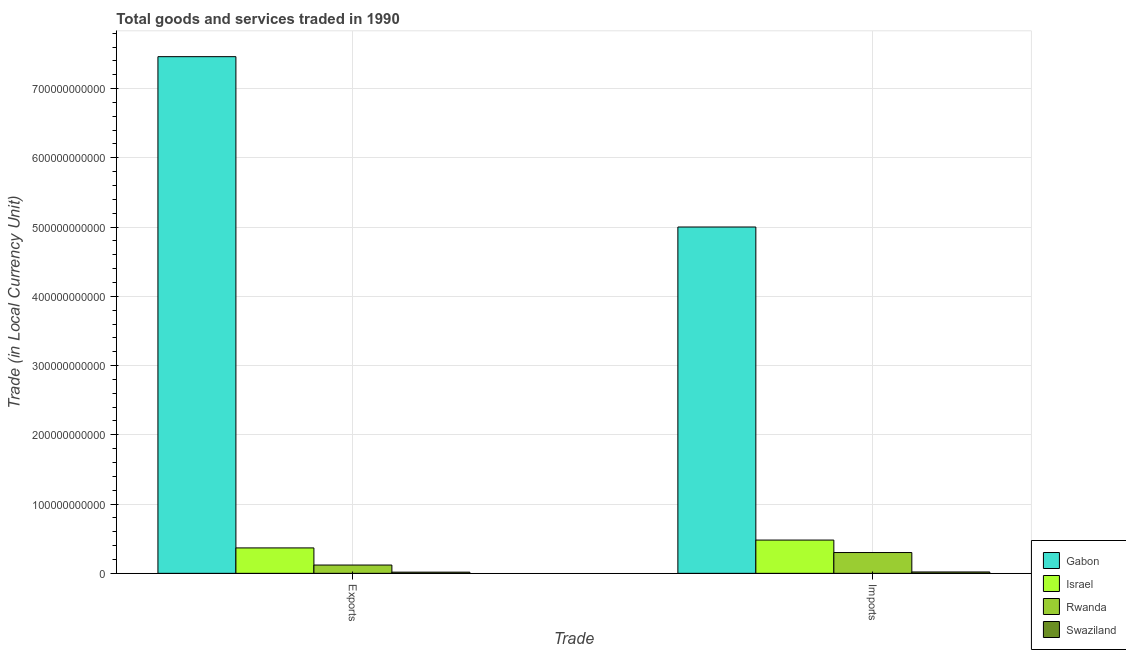How many different coloured bars are there?
Give a very brief answer. 4. How many groups of bars are there?
Provide a succinct answer. 2. What is the label of the 1st group of bars from the left?
Give a very brief answer. Exports. What is the export of goods and services in Israel?
Your answer should be compact. 3.67e+1. Across all countries, what is the maximum export of goods and services?
Your answer should be compact. 7.46e+11. Across all countries, what is the minimum export of goods and services?
Your answer should be compact. 1.70e+09. In which country was the imports of goods and services maximum?
Your response must be concise. Gabon. In which country was the imports of goods and services minimum?
Provide a succinct answer. Swaziland. What is the total export of goods and services in the graph?
Provide a short and direct response. 7.97e+11. What is the difference between the export of goods and services in Gabon and that in Israel?
Provide a succinct answer. 7.09e+11. What is the difference between the export of goods and services in Rwanda and the imports of goods and services in Israel?
Provide a short and direct response. -3.60e+1. What is the average export of goods and services per country?
Provide a succinct answer. 1.99e+11. What is the difference between the export of goods and services and imports of goods and services in Israel?
Give a very brief answer. -1.13e+1. What is the ratio of the imports of goods and services in Rwanda to that in Israel?
Offer a very short reply. 0.63. Is the imports of goods and services in Israel less than that in Rwanda?
Provide a short and direct response. No. What does the 2nd bar from the left in Imports represents?
Keep it short and to the point. Israel. What does the 4th bar from the right in Imports represents?
Keep it short and to the point. Gabon. How many bars are there?
Provide a succinct answer. 8. How many countries are there in the graph?
Keep it short and to the point. 4. What is the difference between two consecutive major ticks on the Y-axis?
Give a very brief answer. 1.00e+11. Are the values on the major ticks of Y-axis written in scientific E-notation?
Make the answer very short. No. Does the graph contain any zero values?
Provide a succinct answer. No. Does the graph contain grids?
Provide a succinct answer. Yes. How are the legend labels stacked?
Make the answer very short. Vertical. What is the title of the graph?
Your response must be concise. Total goods and services traded in 1990. What is the label or title of the X-axis?
Your answer should be compact. Trade. What is the label or title of the Y-axis?
Your answer should be compact. Trade (in Local Currency Unit). What is the Trade (in Local Currency Unit) of Gabon in Exports?
Ensure brevity in your answer.  7.46e+11. What is the Trade (in Local Currency Unit) in Israel in Exports?
Provide a succinct answer. 3.67e+1. What is the Trade (in Local Currency Unit) of Rwanda in Exports?
Your answer should be compact. 1.20e+1. What is the Trade (in Local Currency Unit) in Swaziland in Exports?
Provide a succinct answer. 1.70e+09. What is the Trade (in Local Currency Unit) of Gabon in Imports?
Offer a very short reply. 5.00e+11. What is the Trade (in Local Currency Unit) in Israel in Imports?
Make the answer very short. 4.80e+1. What is the Trade (in Local Currency Unit) in Rwanda in Imports?
Keep it short and to the point. 3.00e+1. What is the Trade (in Local Currency Unit) in Swaziland in Imports?
Provide a succinct answer. 1.99e+09. Across all Trade, what is the maximum Trade (in Local Currency Unit) in Gabon?
Ensure brevity in your answer.  7.46e+11. Across all Trade, what is the maximum Trade (in Local Currency Unit) of Israel?
Your answer should be very brief. 4.80e+1. Across all Trade, what is the maximum Trade (in Local Currency Unit) in Rwanda?
Offer a very short reply. 3.00e+1. Across all Trade, what is the maximum Trade (in Local Currency Unit) in Swaziland?
Offer a terse response. 1.99e+09. Across all Trade, what is the minimum Trade (in Local Currency Unit) in Gabon?
Make the answer very short. 5.00e+11. Across all Trade, what is the minimum Trade (in Local Currency Unit) of Israel?
Your response must be concise. 3.67e+1. Across all Trade, what is the minimum Trade (in Local Currency Unit) in Rwanda?
Your answer should be compact. 1.20e+1. Across all Trade, what is the minimum Trade (in Local Currency Unit) of Swaziland?
Your answer should be compact. 1.70e+09. What is the total Trade (in Local Currency Unit) of Gabon in the graph?
Provide a short and direct response. 1.25e+12. What is the total Trade (in Local Currency Unit) in Israel in the graph?
Your answer should be compact. 8.47e+1. What is the total Trade (in Local Currency Unit) in Rwanda in the graph?
Provide a short and direct response. 4.20e+1. What is the total Trade (in Local Currency Unit) of Swaziland in the graph?
Keep it short and to the point. 3.69e+09. What is the difference between the Trade (in Local Currency Unit) in Gabon in Exports and that in Imports?
Offer a terse response. 2.46e+11. What is the difference between the Trade (in Local Currency Unit) of Israel in Exports and that in Imports?
Give a very brief answer. -1.13e+1. What is the difference between the Trade (in Local Currency Unit) of Rwanda in Exports and that in Imports?
Offer a terse response. -1.80e+1. What is the difference between the Trade (in Local Currency Unit) in Swaziland in Exports and that in Imports?
Your answer should be very brief. -2.84e+08. What is the difference between the Trade (in Local Currency Unit) in Gabon in Exports and the Trade (in Local Currency Unit) in Israel in Imports?
Provide a succinct answer. 6.98e+11. What is the difference between the Trade (in Local Currency Unit) of Gabon in Exports and the Trade (in Local Currency Unit) of Rwanda in Imports?
Offer a very short reply. 7.16e+11. What is the difference between the Trade (in Local Currency Unit) in Gabon in Exports and the Trade (in Local Currency Unit) in Swaziland in Imports?
Give a very brief answer. 7.44e+11. What is the difference between the Trade (in Local Currency Unit) of Israel in Exports and the Trade (in Local Currency Unit) of Rwanda in Imports?
Your answer should be compact. 6.68e+09. What is the difference between the Trade (in Local Currency Unit) of Israel in Exports and the Trade (in Local Currency Unit) of Swaziland in Imports?
Offer a very short reply. 3.47e+1. What is the difference between the Trade (in Local Currency Unit) in Rwanda in Exports and the Trade (in Local Currency Unit) in Swaziland in Imports?
Ensure brevity in your answer.  1.00e+1. What is the average Trade (in Local Currency Unit) in Gabon per Trade?
Your answer should be very brief. 6.23e+11. What is the average Trade (in Local Currency Unit) of Israel per Trade?
Provide a succinct answer. 4.24e+1. What is the average Trade (in Local Currency Unit) of Rwanda per Trade?
Give a very brief answer. 2.10e+1. What is the average Trade (in Local Currency Unit) of Swaziland per Trade?
Your response must be concise. 1.84e+09. What is the difference between the Trade (in Local Currency Unit) in Gabon and Trade (in Local Currency Unit) in Israel in Exports?
Ensure brevity in your answer.  7.09e+11. What is the difference between the Trade (in Local Currency Unit) in Gabon and Trade (in Local Currency Unit) in Rwanda in Exports?
Your answer should be compact. 7.34e+11. What is the difference between the Trade (in Local Currency Unit) of Gabon and Trade (in Local Currency Unit) of Swaziland in Exports?
Offer a terse response. 7.44e+11. What is the difference between the Trade (in Local Currency Unit) in Israel and Trade (in Local Currency Unit) in Rwanda in Exports?
Offer a terse response. 2.47e+1. What is the difference between the Trade (in Local Currency Unit) in Israel and Trade (in Local Currency Unit) in Swaziland in Exports?
Give a very brief answer. 3.50e+1. What is the difference between the Trade (in Local Currency Unit) in Rwanda and Trade (in Local Currency Unit) in Swaziland in Exports?
Provide a succinct answer. 1.03e+1. What is the difference between the Trade (in Local Currency Unit) in Gabon and Trade (in Local Currency Unit) in Israel in Imports?
Your answer should be very brief. 4.52e+11. What is the difference between the Trade (in Local Currency Unit) of Gabon and Trade (in Local Currency Unit) of Rwanda in Imports?
Your response must be concise. 4.70e+11. What is the difference between the Trade (in Local Currency Unit) of Gabon and Trade (in Local Currency Unit) of Swaziland in Imports?
Provide a short and direct response. 4.98e+11. What is the difference between the Trade (in Local Currency Unit) in Israel and Trade (in Local Currency Unit) in Rwanda in Imports?
Make the answer very short. 1.80e+1. What is the difference between the Trade (in Local Currency Unit) of Israel and Trade (in Local Currency Unit) of Swaziland in Imports?
Keep it short and to the point. 4.60e+1. What is the difference between the Trade (in Local Currency Unit) in Rwanda and Trade (in Local Currency Unit) in Swaziland in Imports?
Your response must be concise. 2.80e+1. What is the ratio of the Trade (in Local Currency Unit) of Gabon in Exports to that in Imports?
Give a very brief answer. 1.49. What is the ratio of the Trade (in Local Currency Unit) in Israel in Exports to that in Imports?
Offer a terse response. 0.76. What is the ratio of the Trade (in Local Currency Unit) of Rwanda in Exports to that in Imports?
Make the answer very short. 0.4. What is the ratio of the Trade (in Local Currency Unit) of Swaziland in Exports to that in Imports?
Provide a succinct answer. 0.86. What is the difference between the highest and the second highest Trade (in Local Currency Unit) in Gabon?
Provide a succinct answer. 2.46e+11. What is the difference between the highest and the second highest Trade (in Local Currency Unit) of Israel?
Your response must be concise. 1.13e+1. What is the difference between the highest and the second highest Trade (in Local Currency Unit) of Rwanda?
Make the answer very short. 1.80e+1. What is the difference between the highest and the second highest Trade (in Local Currency Unit) in Swaziland?
Provide a succinct answer. 2.84e+08. What is the difference between the highest and the lowest Trade (in Local Currency Unit) in Gabon?
Provide a succinct answer. 2.46e+11. What is the difference between the highest and the lowest Trade (in Local Currency Unit) in Israel?
Ensure brevity in your answer.  1.13e+1. What is the difference between the highest and the lowest Trade (in Local Currency Unit) in Rwanda?
Your answer should be compact. 1.80e+1. What is the difference between the highest and the lowest Trade (in Local Currency Unit) in Swaziland?
Offer a terse response. 2.84e+08. 